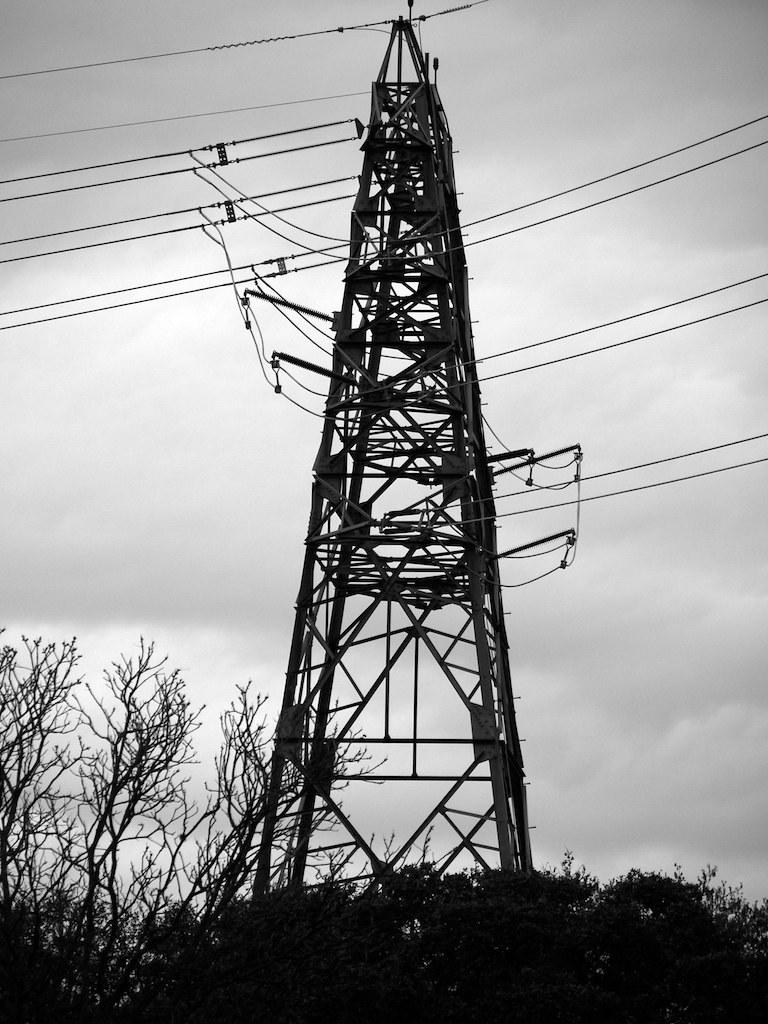What is the color scheme of the image? The image is black and white. What is the main structure featured in the image? There is a tower in the image. What else can be seen in the image besides the tower? There are wires in the image. What is visible in the background of the image? The sky with clouds is visible in the background of the image. What type of vegetation is present at the bottom of the image? Trees are present at the bottom of the image. What type of toe can be seen on the tower in the image? There are no toes present in the image, as it features a tower, wires, and trees in a black and white setting. 